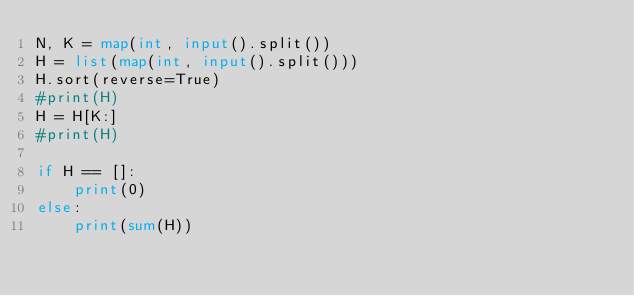Convert code to text. <code><loc_0><loc_0><loc_500><loc_500><_Python_>N, K = map(int, input().split())
H = list(map(int, input().split()))
H.sort(reverse=True)
#print(H)
H = H[K:]
#print(H)

if H == []:
    print(0)
else:
    print(sum(H))</code> 